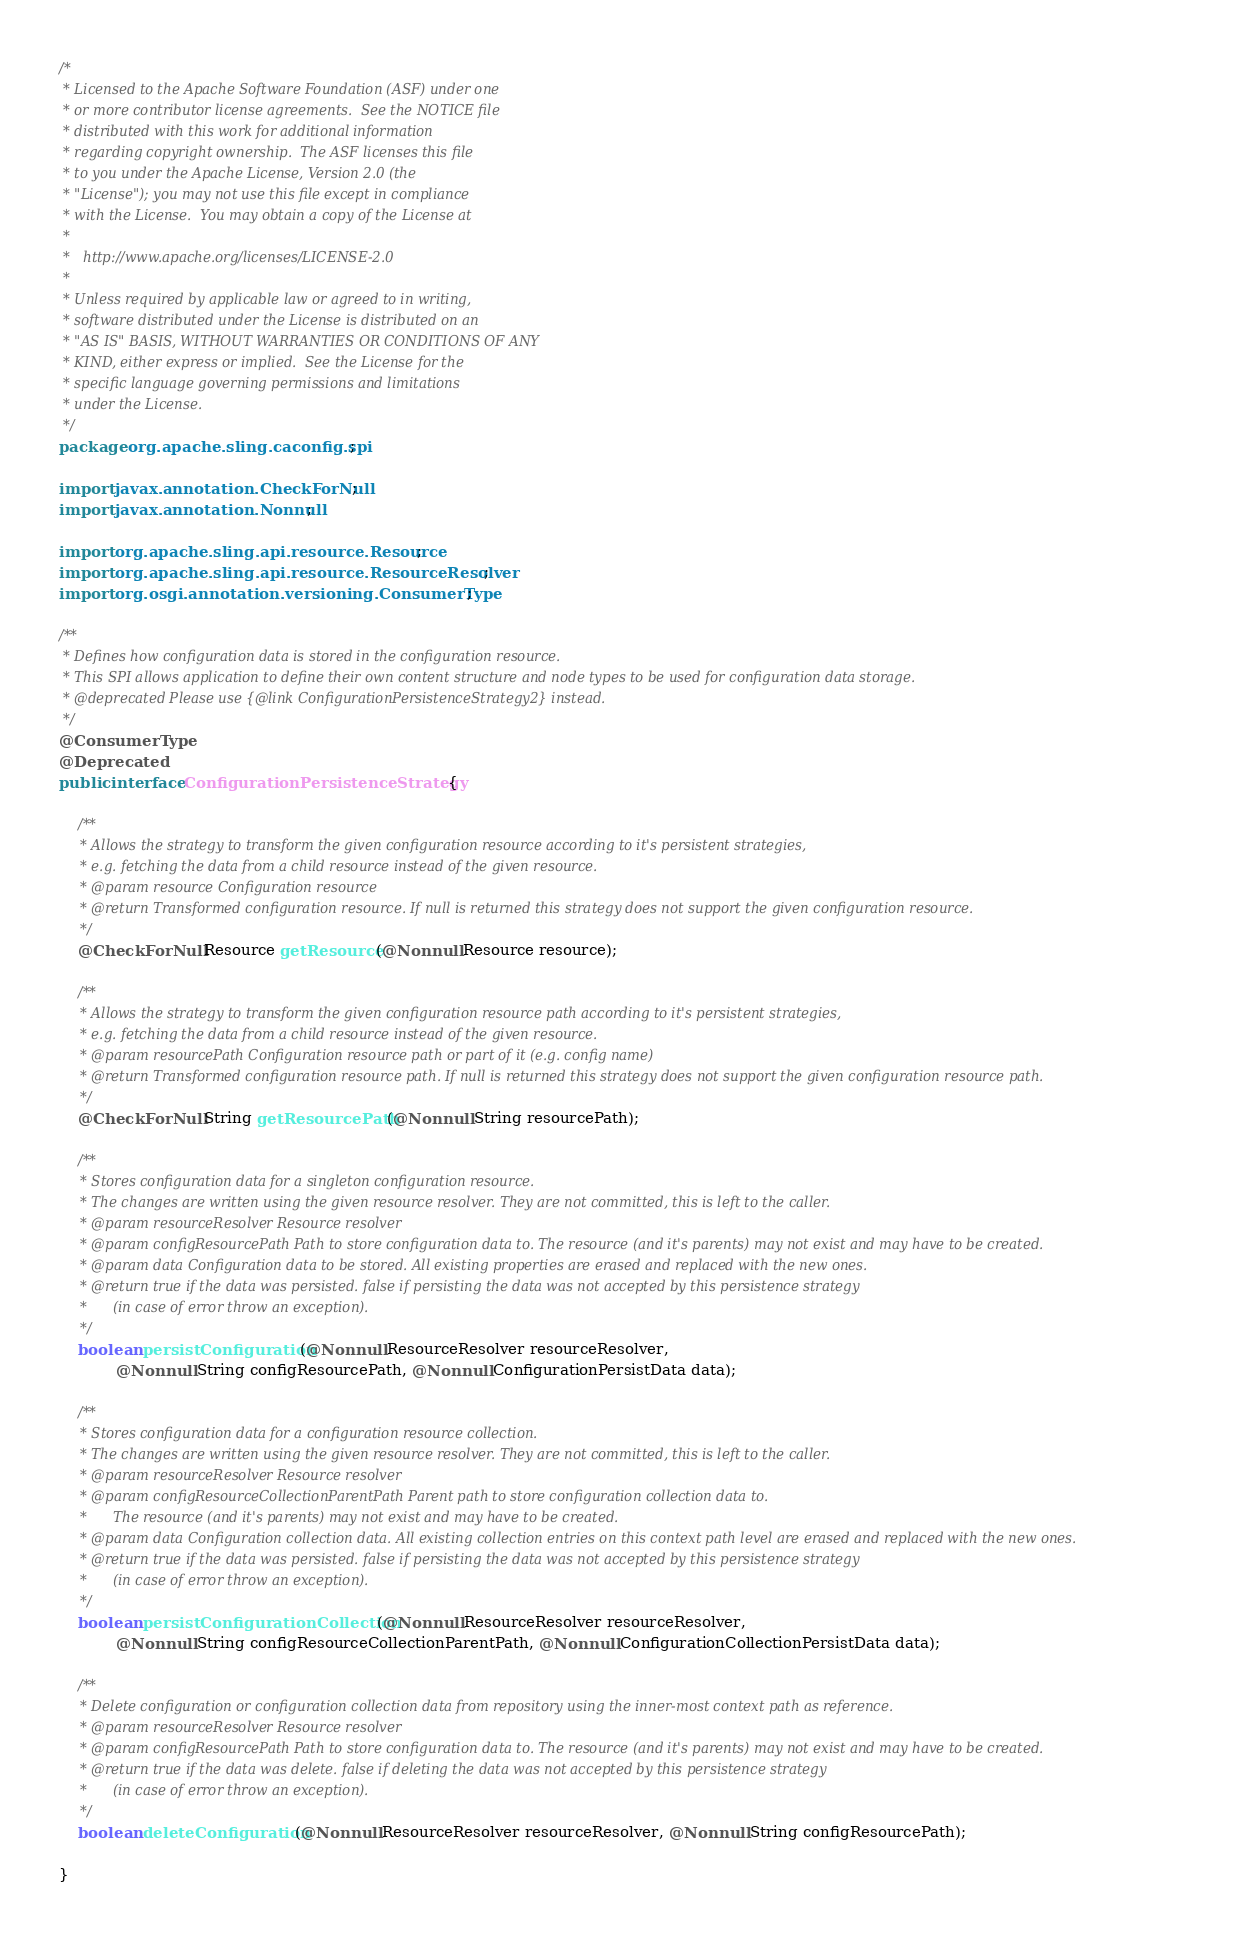<code> <loc_0><loc_0><loc_500><loc_500><_Java_>/*
 * Licensed to the Apache Software Foundation (ASF) under one
 * or more contributor license agreements.  See the NOTICE file
 * distributed with this work for additional information
 * regarding copyright ownership.  The ASF licenses this file
 * to you under the Apache License, Version 2.0 (the
 * "License"); you may not use this file except in compliance
 * with the License.  You may obtain a copy of the License at
 *
 *   http://www.apache.org/licenses/LICENSE-2.0
 *
 * Unless required by applicable law or agreed to in writing,
 * software distributed under the License is distributed on an
 * "AS IS" BASIS, WITHOUT WARRANTIES OR CONDITIONS OF ANY
 * KIND, either express or implied.  See the License for the
 * specific language governing permissions and limitations
 * under the License.
 */
package org.apache.sling.caconfig.spi;

import javax.annotation.CheckForNull;
import javax.annotation.Nonnull;

import org.apache.sling.api.resource.Resource;
import org.apache.sling.api.resource.ResourceResolver;
import org.osgi.annotation.versioning.ConsumerType;

/**
 * Defines how configuration data is stored in the configuration resource.
 * This SPI allows application to define their own content structure and node types to be used for configuration data storage.
 * @deprecated Please use {@link ConfigurationPersistenceStrategy2} instead.
 */
@ConsumerType
@Deprecated
public interface ConfigurationPersistenceStrategy {

    /**
     * Allows the strategy to transform the given configuration resource according to it's persistent strategies,
     * e.g. fetching the data from a child resource instead of the given resource. 
     * @param resource Configuration resource
     * @return Transformed configuration resource. If null is returned this strategy does not support the given configuration resource.
     */
    @CheckForNull Resource getResource(@Nonnull Resource resource);
    
    /**
     * Allows the strategy to transform the given configuration resource path according to it's persistent strategies,
     * e.g. fetching the data from a child resource instead of the given resource. 
     * @param resourcePath Configuration resource path or part of it (e.g. config name)
     * @return Transformed configuration resource path. If null is returned this strategy does not support the given configuration resource path.
     */
    @CheckForNull String getResourcePath(@Nonnull String resourcePath);
    
    /**
     * Stores configuration data for a singleton configuration resource.
     * The changes are written using the given resource resolver. They are not committed, this is left to the caller.
     * @param resourceResolver Resource resolver
     * @param configResourcePath Path to store configuration data to. The resource (and it's parents) may not exist and may have to be created. 
     * @param data Configuration data to be stored. All existing properties are erased and replaced with the new ones.
     * @return true if the data was persisted. false if persisting the data was not accepted by this persistence strategy
     *      (in case of error throw an exception).
     */
    boolean persistConfiguration(@Nonnull ResourceResolver resourceResolver,
            @Nonnull String configResourcePath, @Nonnull ConfigurationPersistData data);
    
    /**
     * Stores configuration data for a configuration resource collection.
     * The changes are written using the given resource resolver. They are not committed, this is left to the caller.
     * @param resourceResolver Resource resolver
     * @param configResourceCollectionParentPath Parent path to store configuration collection data to.
     *      The resource (and it's parents) may not exist and may have to be created. 
     * @param data Configuration collection data. All existing collection entries on this context path level are erased and replaced with the new ones.
     * @return true if the data was persisted. false if persisting the data was not accepted by this persistence strategy
     *      (in case of error throw an exception).
     */
    boolean persistConfigurationCollection(@Nonnull ResourceResolver resourceResolver,
            @Nonnull String configResourceCollectionParentPath, @Nonnull ConfigurationCollectionPersistData data);
 
    /**
     * Delete configuration or configuration collection data from repository using the inner-most context path as reference.
     * @param resourceResolver Resource resolver
     * @param configResourcePath Path to store configuration data to. The resource (and it's parents) may not exist and may have to be created. 
     * @return true if the data was delete. false if deleting the data was not accepted by this persistence strategy
     *      (in case of error throw an exception).
     */
    boolean deleteConfiguration(@Nonnull ResourceResolver resourceResolver, @Nonnull String configResourcePath);
    
}
</code> 